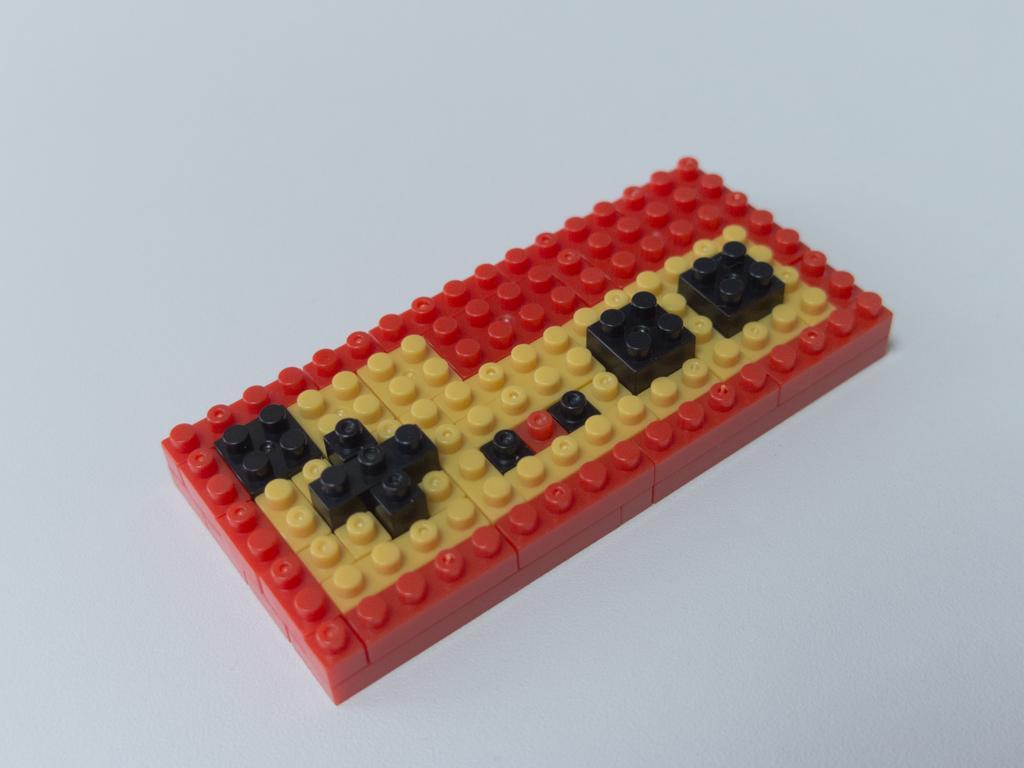Could you give a brief overview of what you see in this image? In this image we can see a lego block. 